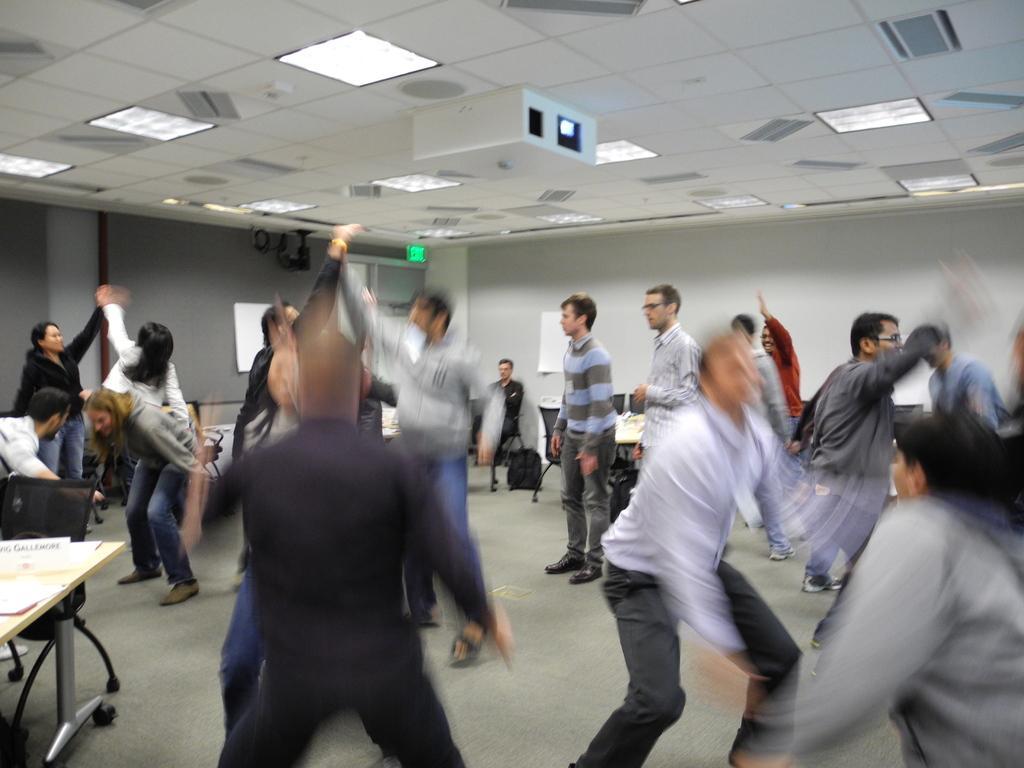How would you summarize this image in a sentence or two? In the picture I can see a group of people dancing on the floor. I can see a man sitting on the chair. I can see the tables and chairs on the floor. There is a lighting arrangement on the roof. I can see a projector on the roof at the top of the picture. 